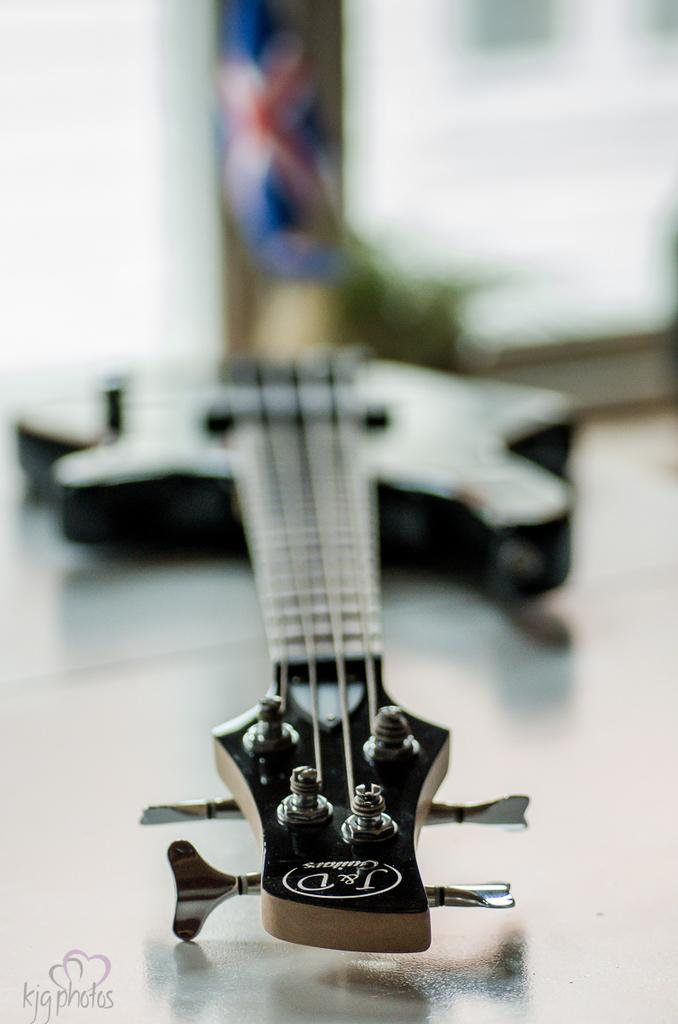What musical instrument is present in the image? There is a guitar in the image. Where is the guitar located? The guitar is placed on a table. How many points does the guitar have in the image? The guitar does not have points; it is a musical instrument with strings and a body. 